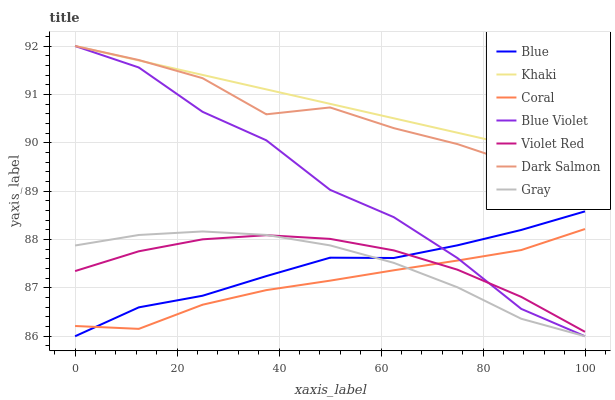Does Coral have the minimum area under the curve?
Answer yes or no. Yes. Does Khaki have the maximum area under the curve?
Answer yes or no. Yes. Does Gray have the minimum area under the curve?
Answer yes or no. No. Does Gray have the maximum area under the curve?
Answer yes or no. No. Is Khaki the smoothest?
Answer yes or no. Yes. Is Blue Violet the roughest?
Answer yes or no. Yes. Is Gray the smoothest?
Answer yes or no. No. Is Gray the roughest?
Answer yes or no. No. Does Blue have the lowest value?
Answer yes or no. Yes. Does Violet Red have the lowest value?
Answer yes or no. No. Does Blue Violet have the highest value?
Answer yes or no. Yes. Does Gray have the highest value?
Answer yes or no. No. Is Coral less than Dark Salmon?
Answer yes or no. Yes. Is Khaki greater than Coral?
Answer yes or no. Yes. Does Coral intersect Blue Violet?
Answer yes or no. Yes. Is Coral less than Blue Violet?
Answer yes or no. No. Is Coral greater than Blue Violet?
Answer yes or no. No. Does Coral intersect Dark Salmon?
Answer yes or no. No. 